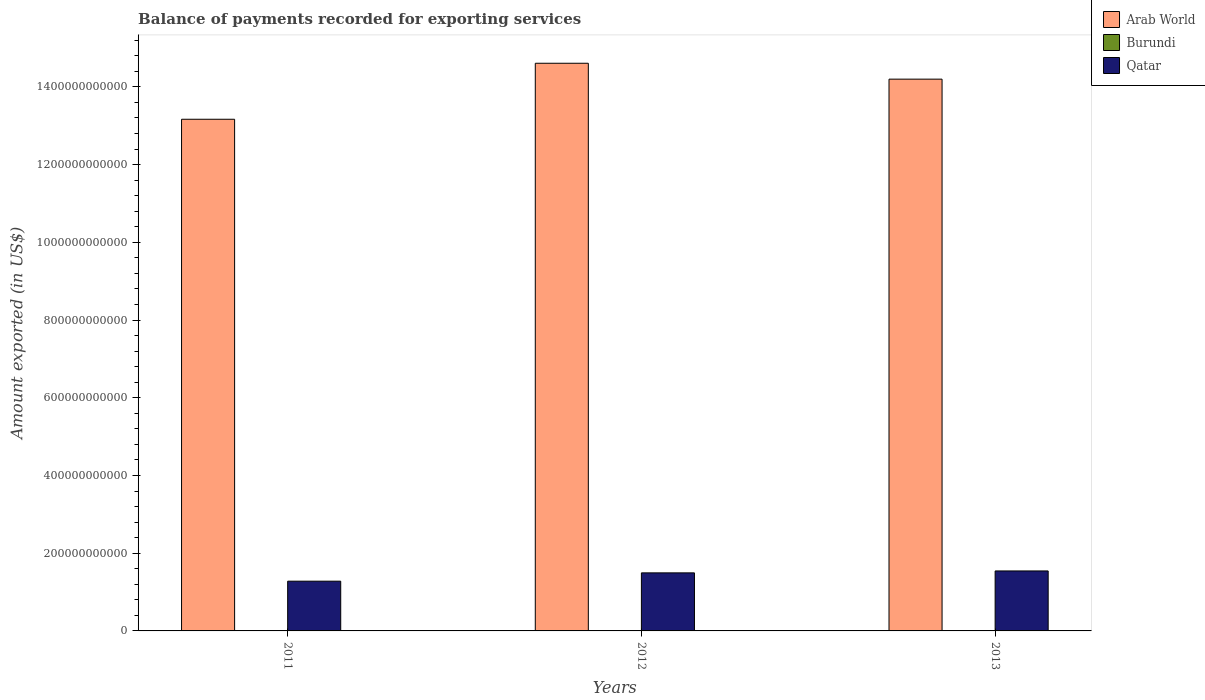How many groups of bars are there?
Keep it short and to the point. 3. Are the number of bars per tick equal to the number of legend labels?
Provide a succinct answer. Yes. How many bars are there on the 1st tick from the left?
Offer a very short reply. 3. In how many cases, is the number of bars for a given year not equal to the number of legend labels?
Ensure brevity in your answer.  0. What is the amount exported in Qatar in 2011?
Keep it short and to the point. 1.28e+11. Across all years, what is the maximum amount exported in Arab World?
Ensure brevity in your answer.  1.46e+12. Across all years, what is the minimum amount exported in Burundi?
Provide a short and direct response. 2.36e+08. In which year was the amount exported in Qatar maximum?
Ensure brevity in your answer.  2013. What is the total amount exported in Qatar in the graph?
Offer a terse response. 4.32e+11. What is the difference between the amount exported in Qatar in 2012 and that in 2013?
Your answer should be very brief. -4.94e+09. What is the difference between the amount exported in Qatar in 2011 and the amount exported in Burundi in 2012?
Ensure brevity in your answer.  1.28e+11. What is the average amount exported in Burundi per year?
Give a very brief answer. 2.39e+08. In the year 2011, what is the difference between the amount exported in Burundi and amount exported in Qatar?
Ensure brevity in your answer.  -1.28e+11. What is the ratio of the amount exported in Arab World in 2011 to that in 2012?
Make the answer very short. 0.9. Is the difference between the amount exported in Burundi in 2011 and 2012 greater than the difference between the amount exported in Qatar in 2011 and 2012?
Ensure brevity in your answer.  Yes. What is the difference between the highest and the second highest amount exported in Arab World?
Keep it short and to the point. 4.09e+1. What is the difference between the highest and the lowest amount exported in Burundi?
Offer a terse response. 7.00e+06. What does the 1st bar from the left in 2012 represents?
Your answer should be very brief. Arab World. What does the 2nd bar from the right in 2012 represents?
Your answer should be compact. Burundi. Is it the case that in every year, the sum of the amount exported in Burundi and amount exported in Arab World is greater than the amount exported in Qatar?
Provide a succinct answer. Yes. What is the difference between two consecutive major ticks on the Y-axis?
Provide a succinct answer. 2.00e+11. Does the graph contain any zero values?
Keep it short and to the point. No. Where does the legend appear in the graph?
Offer a very short reply. Top right. How many legend labels are there?
Make the answer very short. 3. What is the title of the graph?
Your answer should be very brief. Balance of payments recorded for exporting services. Does "Austria" appear as one of the legend labels in the graph?
Offer a very short reply. No. What is the label or title of the X-axis?
Keep it short and to the point. Years. What is the label or title of the Y-axis?
Give a very brief answer. Amount exported (in US$). What is the Amount exported (in US$) in Arab World in 2011?
Offer a very short reply. 1.32e+12. What is the Amount exported (in US$) in Burundi in 2011?
Make the answer very short. 2.43e+08. What is the Amount exported (in US$) of Qatar in 2011?
Provide a succinct answer. 1.28e+11. What is the Amount exported (in US$) of Arab World in 2012?
Keep it short and to the point. 1.46e+12. What is the Amount exported (in US$) in Burundi in 2012?
Provide a short and direct response. 2.39e+08. What is the Amount exported (in US$) in Qatar in 2012?
Offer a very short reply. 1.49e+11. What is the Amount exported (in US$) in Arab World in 2013?
Your answer should be very brief. 1.42e+12. What is the Amount exported (in US$) of Burundi in 2013?
Make the answer very short. 2.36e+08. What is the Amount exported (in US$) of Qatar in 2013?
Provide a succinct answer. 1.54e+11. Across all years, what is the maximum Amount exported (in US$) of Arab World?
Provide a short and direct response. 1.46e+12. Across all years, what is the maximum Amount exported (in US$) in Burundi?
Offer a terse response. 2.43e+08. Across all years, what is the maximum Amount exported (in US$) of Qatar?
Make the answer very short. 1.54e+11. Across all years, what is the minimum Amount exported (in US$) in Arab World?
Your response must be concise. 1.32e+12. Across all years, what is the minimum Amount exported (in US$) of Burundi?
Offer a very short reply. 2.36e+08. Across all years, what is the minimum Amount exported (in US$) of Qatar?
Keep it short and to the point. 1.28e+11. What is the total Amount exported (in US$) of Arab World in the graph?
Ensure brevity in your answer.  4.20e+12. What is the total Amount exported (in US$) in Burundi in the graph?
Make the answer very short. 7.18e+08. What is the total Amount exported (in US$) of Qatar in the graph?
Your response must be concise. 4.32e+11. What is the difference between the Amount exported (in US$) of Arab World in 2011 and that in 2012?
Your answer should be very brief. -1.44e+11. What is the difference between the Amount exported (in US$) of Burundi in 2011 and that in 2012?
Provide a succinct answer. 4.17e+06. What is the difference between the Amount exported (in US$) in Qatar in 2011 and that in 2012?
Make the answer very short. -2.14e+1. What is the difference between the Amount exported (in US$) in Arab World in 2011 and that in 2013?
Ensure brevity in your answer.  -1.03e+11. What is the difference between the Amount exported (in US$) of Burundi in 2011 and that in 2013?
Keep it short and to the point. 7.00e+06. What is the difference between the Amount exported (in US$) in Qatar in 2011 and that in 2013?
Make the answer very short. -2.63e+1. What is the difference between the Amount exported (in US$) of Arab World in 2012 and that in 2013?
Your answer should be very brief. 4.09e+1. What is the difference between the Amount exported (in US$) of Burundi in 2012 and that in 2013?
Give a very brief answer. 2.83e+06. What is the difference between the Amount exported (in US$) of Qatar in 2012 and that in 2013?
Provide a short and direct response. -4.94e+09. What is the difference between the Amount exported (in US$) in Arab World in 2011 and the Amount exported (in US$) in Burundi in 2012?
Keep it short and to the point. 1.32e+12. What is the difference between the Amount exported (in US$) in Arab World in 2011 and the Amount exported (in US$) in Qatar in 2012?
Provide a short and direct response. 1.17e+12. What is the difference between the Amount exported (in US$) of Burundi in 2011 and the Amount exported (in US$) of Qatar in 2012?
Offer a very short reply. -1.49e+11. What is the difference between the Amount exported (in US$) in Arab World in 2011 and the Amount exported (in US$) in Burundi in 2013?
Your answer should be very brief. 1.32e+12. What is the difference between the Amount exported (in US$) of Arab World in 2011 and the Amount exported (in US$) of Qatar in 2013?
Make the answer very short. 1.16e+12. What is the difference between the Amount exported (in US$) of Burundi in 2011 and the Amount exported (in US$) of Qatar in 2013?
Offer a very short reply. -1.54e+11. What is the difference between the Amount exported (in US$) in Arab World in 2012 and the Amount exported (in US$) in Burundi in 2013?
Your response must be concise. 1.46e+12. What is the difference between the Amount exported (in US$) in Arab World in 2012 and the Amount exported (in US$) in Qatar in 2013?
Provide a short and direct response. 1.31e+12. What is the difference between the Amount exported (in US$) in Burundi in 2012 and the Amount exported (in US$) in Qatar in 2013?
Offer a very short reply. -1.54e+11. What is the average Amount exported (in US$) in Arab World per year?
Provide a short and direct response. 1.40e+12. What is the average Amount exported (in US$) of Burundi per year?
Give a very brief answer. 2.39e+08. What is the average Amount exported (in US$) in Qatar per year?
Ensure brevity in your answer.  1.44e+11. In the year 2011, what is the difference between the Amount exported (in US$) of Arab World and Amount exported (in US$) of Burundi?
Give a very brief answer. 1.32e+12. In the year 2011, what is the difference between the Amount exported (in US$) in Arab World and Amount exported (in US$) in Qatar?
Your response must be concise. 1.19e+12. In the year 2011, what is the difference between the Amount exported (in US$) in Burundi and Amount exported (in US$) in Qatar?
Make the answer very short. -1.28e+11. In the year 2012, what is the difference between the Amount exported (in US$) in Arab World and Amount exported (in US$) in Burundi?
Give a very brief answer. 1.46e+12. In the year 2012, what is the difference between the Amount exported (in US$) of Arab World and Amount exported (in US$) of Qatar?
Ensure brevity in your answer.  1.31e+12. In the year 2012, what is the difference between the Amount exported (in US$) of Burundi and Amount exported (in US$) of Qatar?
Make the answer very short. -1.49e+11. In the year 2013, what is the difference between the Amount exported (in US$) of Arab World and Amount exported (in US$) of Burundi?
Your answer should be very brief. 1.42e+12. In the year 2013, what is the difference between the Amount exported (in US$) in Arab World and Amount exported (in US$) in Qatar?
Give a very brief answer. 1.27e+12. In the year 2013, what is the difference between the Amount exported (in US$) in Burundi and Amount exported (in US$) in Qatar?
Offer a terse response. -1.54e+11. What is the ratio of the Amount exported (in US$) in Arab World in 2011 to that in 2012?
Offer a terse response. 0.9. What is the ratio of the Amount exported (in US$) in Burundi in 2011 to that in 2012?
Ensure brevity in your answer.  1.02. What is the ratio of the Amount exported (in US$) in Qatar in 2011 to that in 2012?
Give a very brief answer. 0.86. What is the ratio of the Amount exported (in US$) of Arab World in 2011 to that in 2013?
Give a very brief answer. 0.93. What is the ratio of the Amount exported (in US$) of Burundi in 2011 to that in 2013?
Give a very brief answer. 1.03. What is the ratio of the Amount exported (in US$) of Qatar in 2011 to that in 2013?
Your answer should be compact. 0.83. What is the ratio of the Amount exported (in US$) in Arab World in 2012 to that in 2013?
Ensure brevity in your answer.  1.03. What is the ratio of the Amount exported (in US$) in Burundi in 2012 to that in 2013?
Give a very brief answer. 1.01. What is the ratio of the Amount exported (in US$) of Qatar in 2012 to that in 2013?
Give a very brief answer. 0.97. What is the difference between the highest and the second highest Amount exported (in US$) of Arab World?
Your response must be concise. 4.09e+1. What is the difference between the highest and the second highest Amount exported (in US$) of Burundi?
Keep it short and to the point. 4.17e+06. What is the difference between the highest and the second highest Amount exported (in US$) of Qatar?
Offer a very short reply. 4.94e+09. What is the difference between the highest and the lowest Amount exported (in US$) in Arab World?
Offer a very short reply. 1.44e+11. What is the difference between the highest and the lowest Amount exported (in US$) in Burundi?
Your answer should be compact. 7.00e+06. What is the difference between the highest and the lowest Amount exported (in US$) of Qatar?
Ensure brevity in your answer.  2.63e+1. 